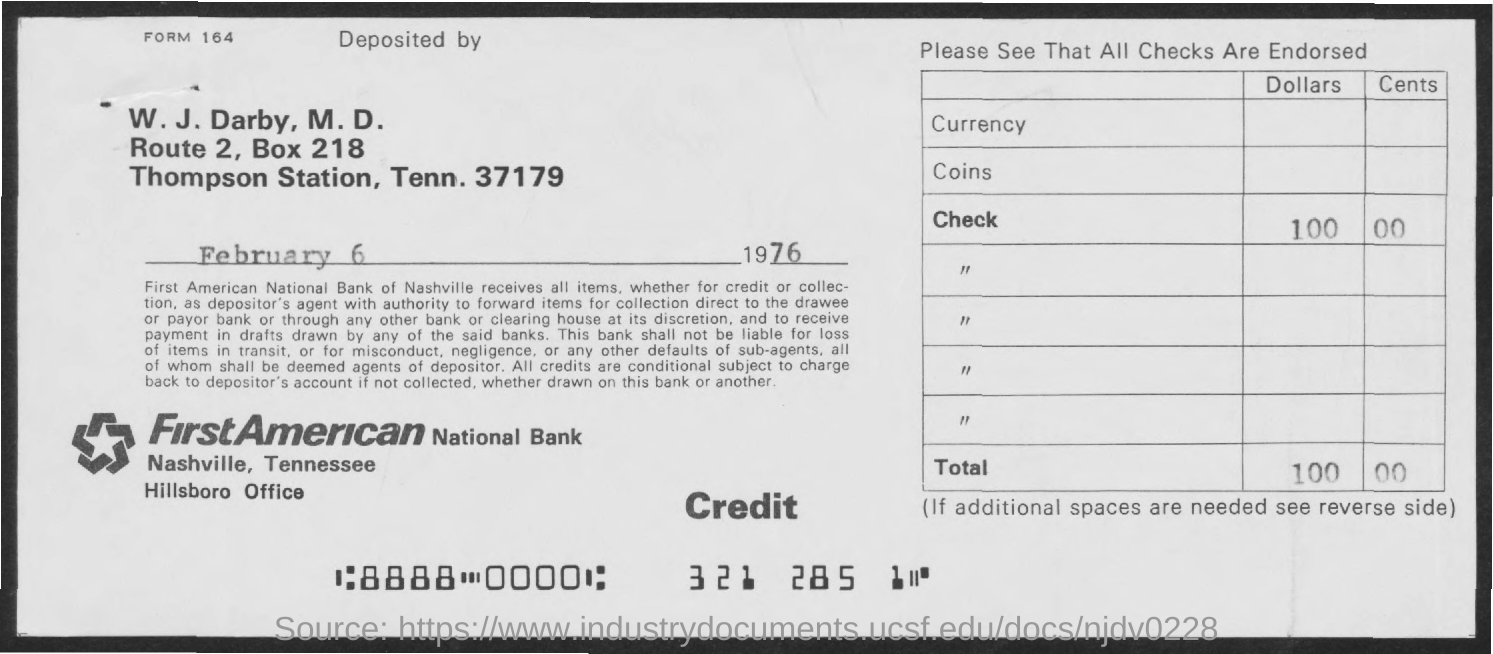What is the BOX Number ?
Your answer should be compact. 218. What is the Bank Name ?
Your response must be concise. FIRSTAMERICAN NATIONAL BANK. 